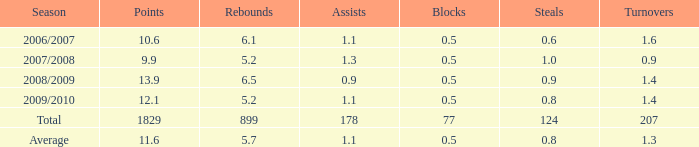Write the full table. {'header': ['Season', 'Points', 'Rebounds', 'Assists', 'Blocks', 'Steals', 'Turnovers'], 'rows': [['2006/2007', '10.6', '6.1', '1.1', '0.5', '0.6', '1.6'], ['2007/2008', '9.9', '5.2', '1.3', '0.5', '1.0', '0.9'], ['2008/2009', '13.9', '6.5', '0.9', '0.5', '0.9', '1.4'], ['2009/2010', '12.1', '5.2', '1.1', '0.5', '0.8', '1.4'], ['Total', '1829', '899', '178', '77', '124', '207'], ['Average', '11.6', '5.7', '1.1', '0.5', '0.8', '1.3']]} How many blocks are there when the rebounds are fewer than 5.2? 0.0. 